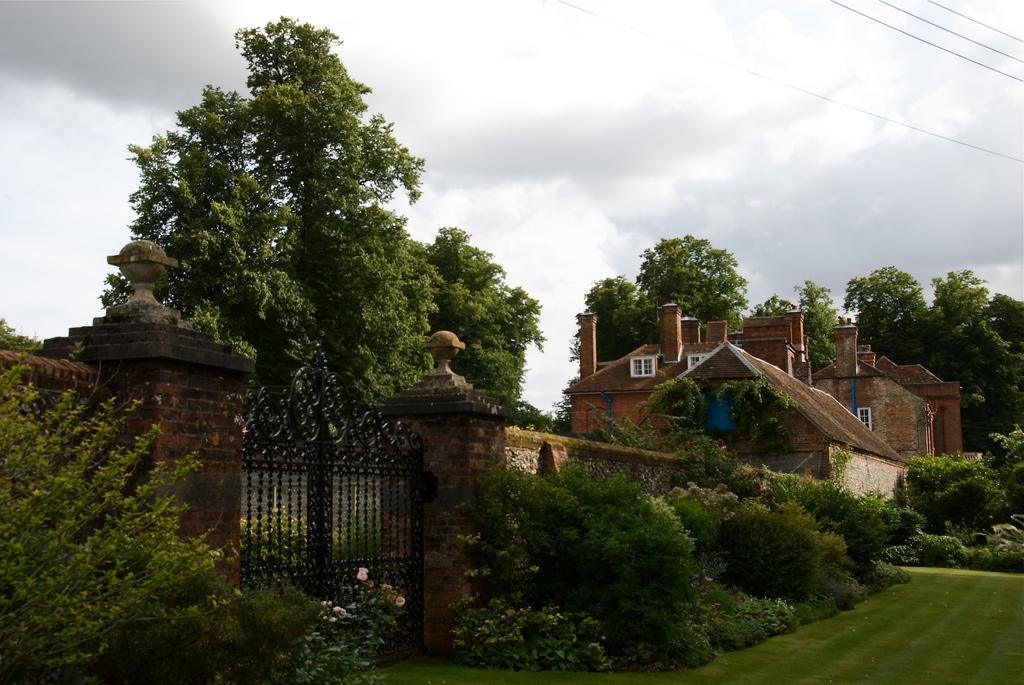Please provide a concise description of this image. Here there is a gate. this is the boundary. Outside the boundary there are many trees, plants. Here there is a building. In the background there are trees. The sky is cloudy. 